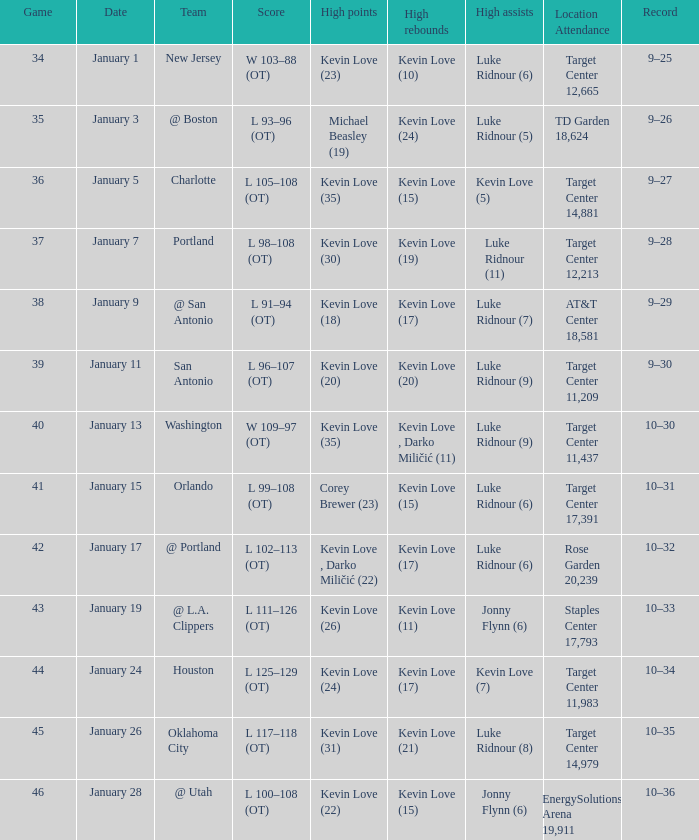How many times was kevin love (22) the top scorer? 1.0. 